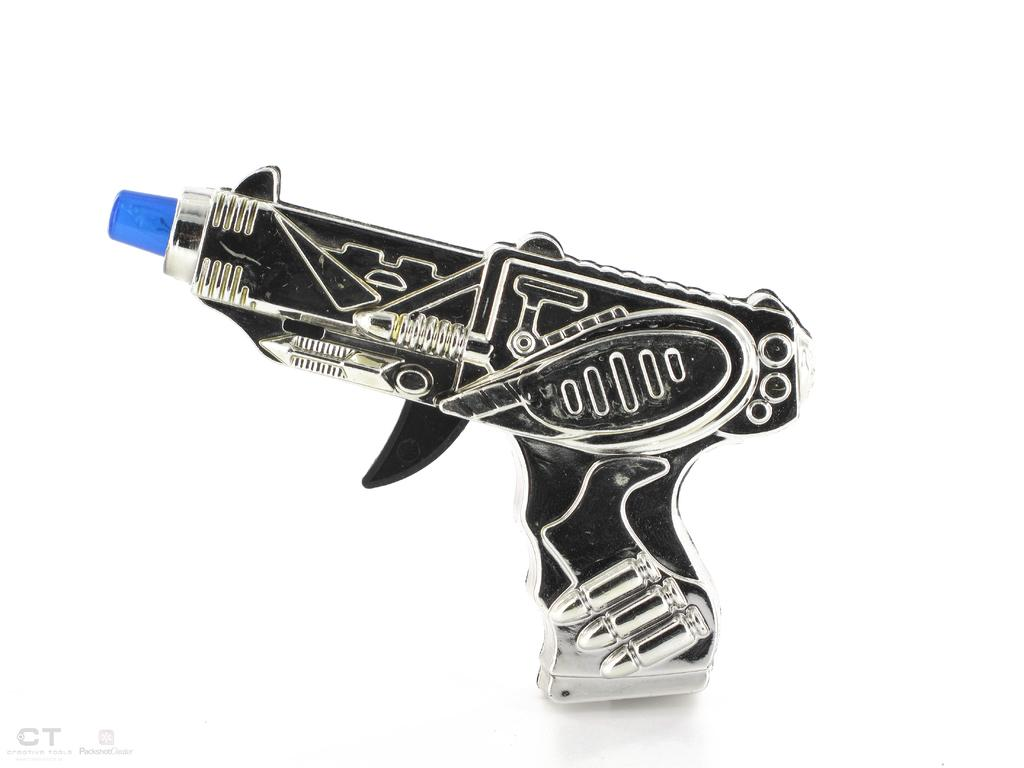What type of toy is present in the image? There is a toy gun in the image. How many cakes are on the table next to the toy gun in the image? There is no table or cakes present in the image; it only features a toy gun. 